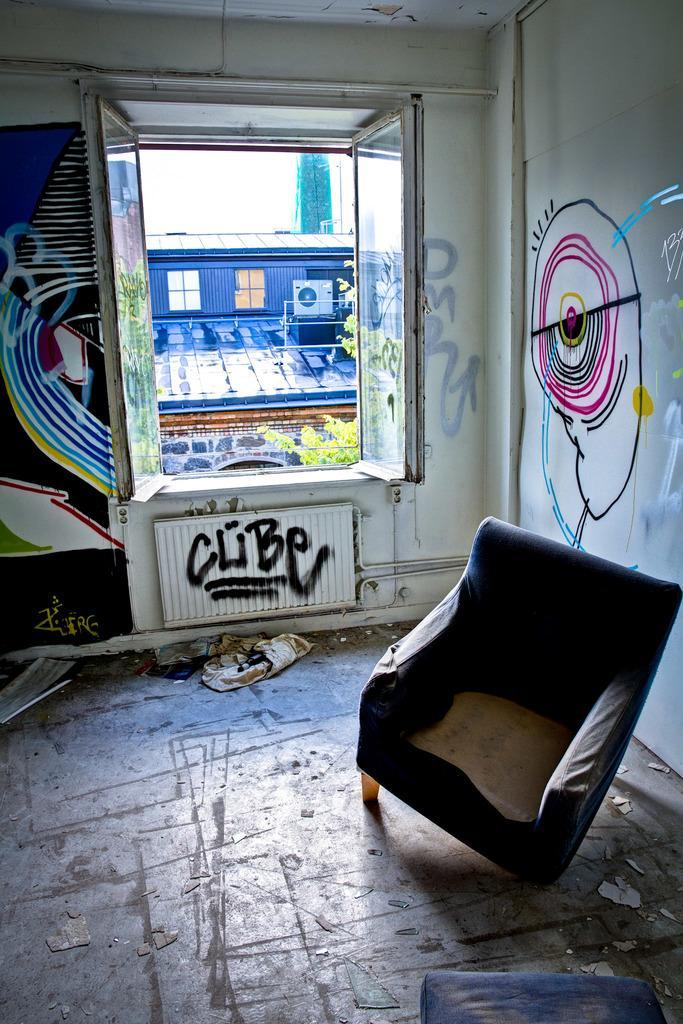Can you describe this image briefly? In this image in the front there is a sofa and on the right side on the wall there is a painting. In the background there is a window and behind the window there are leaves and there is a building and there is a tower and on the left side of the window there is a painting on the wall and there is some text written below the window. 